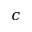Convert formula to latex. <formula><loc_0><loc_0><loc_500><loc_500>c</formula> 